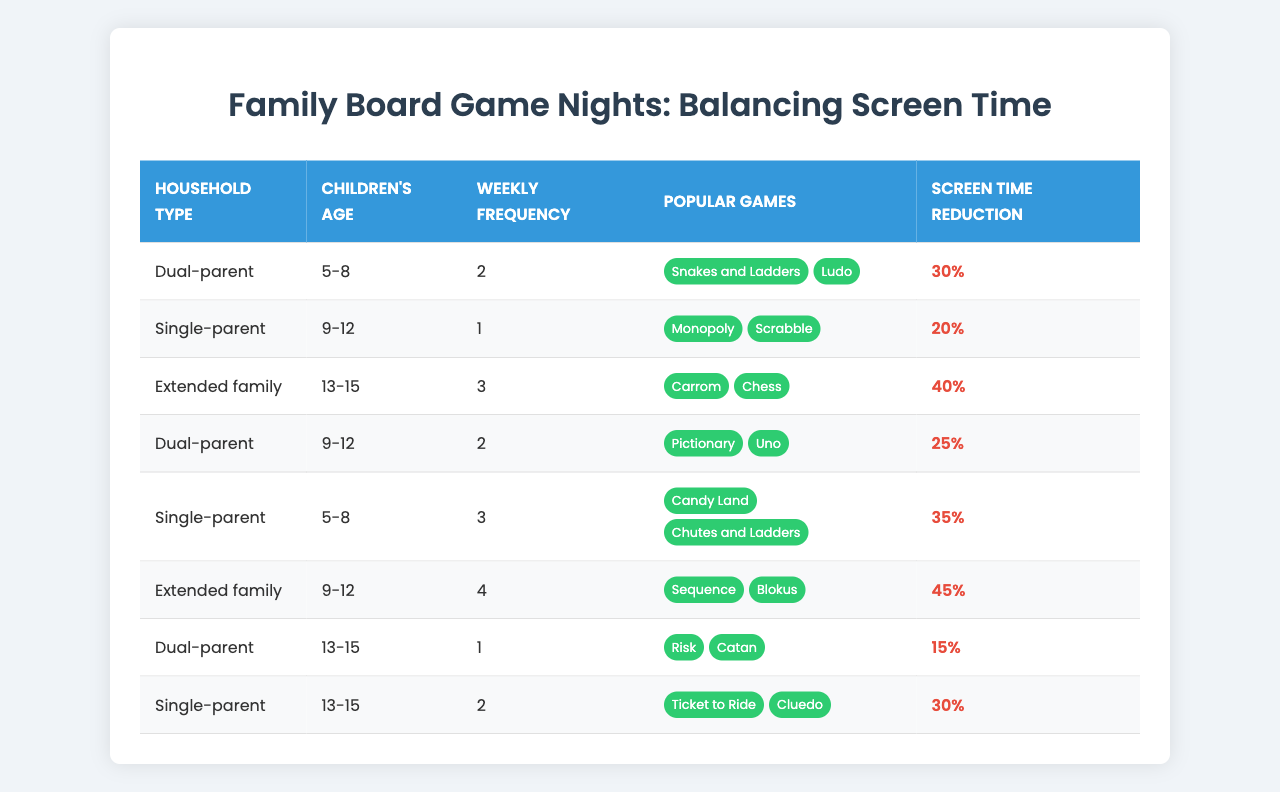What is the weekly frequency of board game nights in dual-parent households with children aged 5-8? According to the table, dual-parent households with children aged 5-8 have a weekly frequency of 2 game nights.
Answer: 2 Which household type has the highest screen time reduction percentage? The extended family with children aged 9-12 has the highest screen time reduction at 45%.
Answer: 45% How many popular games are listed for single-parent households with children aged 5-8? There are 2 popular games listed for single-parent households with children aged 5-8: Candy Land and Chutes and Ladders.
Answer: 2 What is the average weekly frequency of board game nights for single-parent households? The weekly frequencies for single-parent households are 3 (5-8 age) + 1 (9-12 age) + 2 (13-15 age), which sums to 6, and there are 3 households. Therefore, the average is 6/3 = 2.
Answer: 2 Is there a dual-parent household with children aged 13-15 that has a screen time reduction of over 20%? Yes, the dual-parent household with children aged 13-15 has a screen time reduction of 15%, which is not over 20%, but the only household that fits has a higher frequency of 1 game night, not providing a correct answer.
Answer: No What is the total number of board game nights (weekly frequency) across all households with children aged 9-12? The weekly frequencies for children aged 9-12 are 1 (single-parent) + 2 (dual-parent) + 4 (extended family) = 7 total game nights.
Answer: 7 Which age group in single-parent households has the most popular games listed? The age group 5-8 has 2 popular games listed, while the age group 9-12 has 2 and the age group 13-15 has 2; thus they are all equal.
Answer: Tie How do the screen time reductions for dual-parent households with 5-8-year-olds compare to those with 9-12-year-olds? For dual-parent households, the screen time reduction for ages 5-8 is 30%, and for ages 9-12, it is 25%. Therefore, the 5-8 age group has a higher reduction.
Answer: 5-8 age group has a higher reduction 